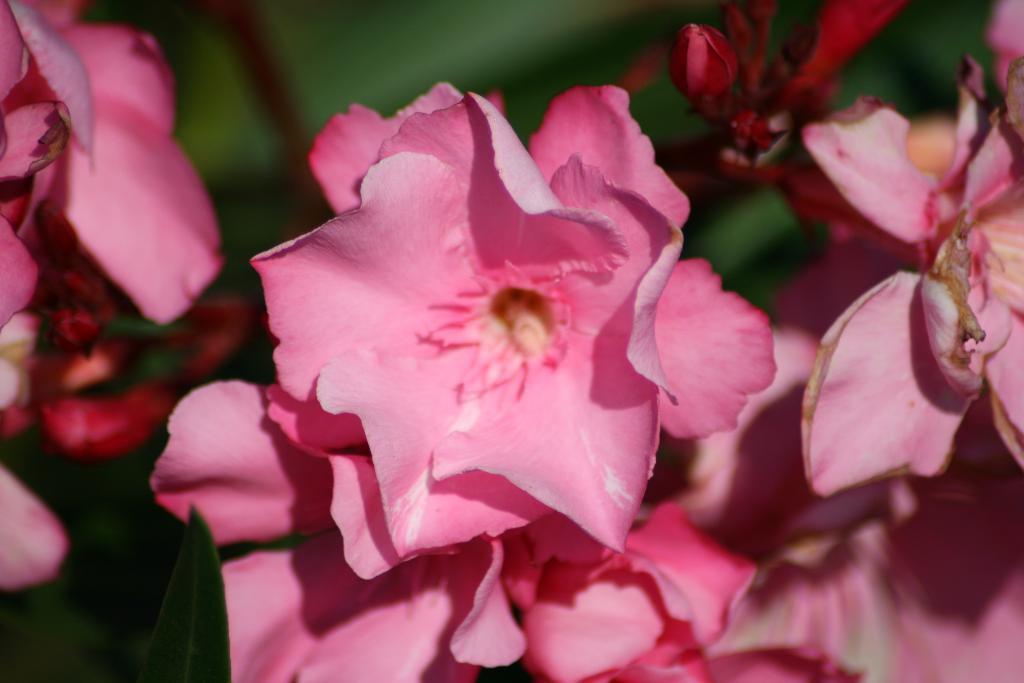Could you give a brief overview of what you see in this image? In this picture, we see the flowers which are in pink color. In the background, it is green in color. This picture is blurred in the background. 